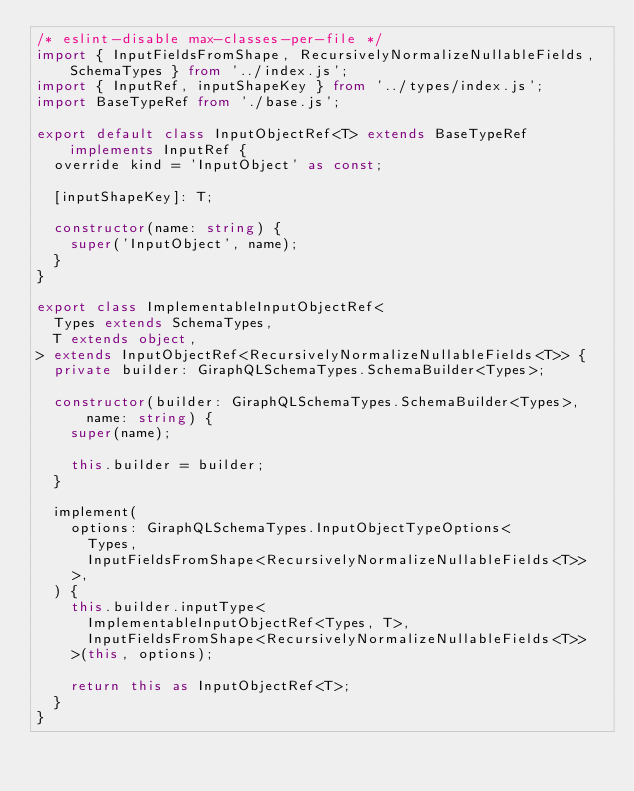<code> <loc_0><loc_0><loc_500><loc_500><_TypeScript_>/* eslint-disable max-classes-per-file */
import { InputFieldsFromShape, RecursivelyNormalizeNullableFields, SchemaTypes } from '../index.js';
import { InputRef, inputShapeKey } from '../types/index.js';
import BaseTypeRef from './base.js';

export default class InputObjectRef<T> extends BaseTypeRef implements InputRef {
  override kind = 'InputObject' as const;

  [inputShapeKey]: T;

  constructor(name: string) {
    super('InputObject', name);
  }
}

export class ImplementableInputObjectRef<
  Types extends SchemaTypes,
  T extends object,
> extends InputObjectRef<RecursivelyNormalizeNullableFields<T>> {
  private builder: GiraphQLSchemaTypes.SchemaBuilder<Types>;

  constructor(builder: GiraphQLSchemaTypes.SchemaBuilder<Types>, name: string) {
    super(name);

    this.builder = builder;
  }

  implement(
    options: GiraphQLSchemaTypes.InputObjectTypeOptions<
      Types,
      InputFieldsFromShape<RecursivelyNormalizeNullableFields<T>>
    >,
  ) {
    this.builder.inputType<
      ImplementableInputObjectRef<Types, T>,
      InputFieldsFromShape<RecursivelyNormalizeNullableFields<T>>
    >(this, options);

    return this as InputObjectRef<T>;
  }
}
</code> 